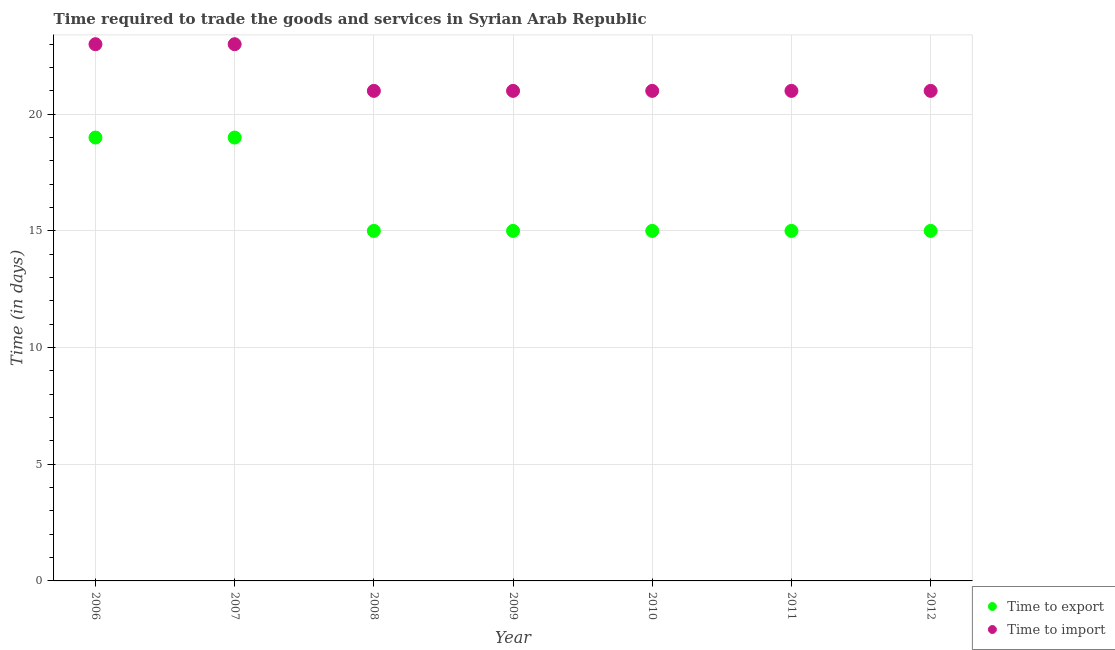How many different coloured dotlines are there?
Give a very brief answer. 2. What is the time to import in 2006?
Offer a terse response. 23. Across all years, what is the maximum time to export?
Your response must be concise. 19. Across all years, what is the minimum time to import?
Your answer should be compact. 21. In which year was the time to import maximum?
Provide a succinct answer. 2006. In which year was the time to export minimum?
Provide a short and direct response. 2008. What is the total time to import in the graph?
Provide a short and direct response. 151. What is the difference between the time to import in 2010 and the time to export in 2012?
Provide a short and direct response. 6. What is the average time to import per year?
Provide a short and direct response. 21.57. In the year 2006, what is the difference between the time to import and time to export?
Your answer should be compact. 4. In how many years, is the time to import greater than 2 days?
Your answer should be very brief. 7. What is the ratio of the time to export in 2007 to that in 2012?
Provide a short and direct response. 1.27. Is the time to import in 2007 less than that in 2009?
Your answer should be compact. No. What is the difference between the highest and the lowest time to import?
Offer a terse response. 2. In how many years, is the time to export greater than the average time to export taken over all years?
Offer a terse response. 2. Is the sum of the time to export in 2007 and 2012 greater than the maximum time to import across all years?
Your answer should be very brief. Yes. Is the time to import strictly greater than the time to export over the years?
Keep it short and to the point. Yes. How many dotlines are there?
Offer a terse response. 2. How many years are there in the graph?
Your answer should be compact. 7. What is the difference between two consecutive major ticks on the Y-axis?
Provide a succinct answer. 5. Does the graph contain any zero values?
Offer a very short reply. No. Where does the legend appear in the graph?
Provide a short and direct response. Bottom right. How are the legend labels stacked?
Provide a short and direct response. Vertical. What is the title of the graph?
Ensure brevity in your answer.  Time required to trade the goods and services in Syrian Arab Republic. What is the label or title of the Y-axis?
Provide a succinct answer. Time (in days). What is the Time (in days) in Time to import in 2006?
Keep it short and to the point. 23. What is the Time (in days) in Time to import in 2007?
Your answer should be compact. 23. What is the Time (in days) of Time to export in 2008?
Offer a very short reply. 15. What is the Time (in days) of Time to import in 2008?
Provide a succinct answer. 21. What is the Time (in days) of Time to import in 2011?
Provide a short and direct response. 21. What is the Time (in days) in Time to export in 2012?
Give a very brief answer. 15. What is the Time (in days) in Time to import in 2012?
Provide a succinct answer. 21. Across all years, what is the minimum Time (in days) in Time to import?
Your response must be concise. 21. What is the total Time (in days) of Time to export in the graph?
Provide a short and direct response. 113. What is the total Time (in days) of Time to import in the graph?
Offer a very short reply. 151. What is the difference between the Time (in days) of Time to export in 2006 and that in 2007?
Ensure brevity in your answer.  0. What is the difference between the Time (in days) of Time to import in 2006 and that in 2007?
Keep it short and to the point. 0. What is the difference between the Time (in days) of Time to export in 2006 and that in 2009?
Offer a terse response. 4. What is the difference between the Time (in days) of Time to import in 2006 and that in 2009?
Offer a terse response. 2. What is the difference between the Time (in days) in Time to export in 2006 and that in 2010?
Offer a terse response. 4. What is the difference between the Time (in days) of Time to export in 2006 and that in 2012?
Offer a terse response. 4. What is the difference between the Time (in days) of Time to import in 2007 and that in 2008?
Your response must be concise. 2. What is the difference between the Time (in days) of Time to export in 2007 and that in 2011?
Your answer should be compact. 4. What is the difference between the Time (in days) in Time to import in 2007 and that in 2011?
Keep it short and to the point. 2. What is the difference between the Time (in days) in Time to export in 2007 and that in 2012?
Give a very brief answer. 4. What is the difference between the Time (in days) in Time to import in 2008 and that in 2010?
Your response must be concise. 0. What is the difference between the Time (in days) of Time to export in 2008 and that in 2012?
Ensure brevity in your answer.  0. What is the difference between the Time (in days) of Time to export in 2009 and that in 2010?
Ensure brevity in your answer.  0. What is the difference between the Time (in days) of Time to export in 2009 and that in 2011?
Keep it short and to the point. 0. What is the difference between the Time (in days) of Time to import in 2009 and that in 2011?
Ensure brevity in your answer.  0. What is the difference between the Time (in days) of Time to import in 2009 and that in 2012?
Provide a succinct answer. 0. What is the difference between the Time (in days) of Time to export in 2010 and that in 2011?
Offer a terse response. 0. What is the difference between the Time (in days) of Time to export in 2010 and that in 2012?
Offer a terse response. 0. What is the difference between the Time (in days) in Time to export in 2006 and the Time (in days) in Time to import in 2008?
Make the answer very short. -2. What is the difference between the Time (in days) in Time to export in 2006 and the Time (in days) in Time to import in 2011?
Provide a succinct answer. -2. What is the difference between the Time (in days) in Time to export in 2006 and the Time (in days) in Time to import in 2012?
Give a very brief answer. -2. What is the difference between the Time (in days) of Time to export in 2007 and the Time (in days) of Time to import in 2008?
Provide a short and direct response. -2. What is the difference between the Time (in days) in Time to export in 2007 and the Time (in days) in Time to import in 2010?
Ensure brevity in your answer.  -2. What is the difference between the Time (in days) in Time to export in 2008 and the Time (in days) in Time to import in 2010?
Keep it short and to the point. -6. What is the difference between the Time (in days) of Time to export in 2008 and the Time (in days) of Time to import in 2011?
Ensure brevity in your answer.  -6. What is the difference between the Time (in days) in Time to export in 2009 and the Time (in days) in Time to import in 2010?
Offer a very short reply. -6. What is the difference between the Time (in days) of Time to export in 2009 and the Time (in days) of Time to import in 2011?
Ensure brevity in your answer.  -6. What is the difference between the Time (in days) in Time to export in 2009 and the Time (in days) in Time to import in 2012?
Your answer should be very brief. -6. What is the difference between the Time (in days) of Time to export in 2010 and the Time (in days) of Time to import in 2011?
Make the answer very short. -6. What is the difference between the Time (in days) in Time to export in 2010 and the Time (in days) in Time to import in 2012?
Provide a succinct answer. -6. What is the difference between the Time (in days) of Time to export in 2011 and the Time (in days) of Time to import in 2012?
Your answer should be compact. -6. What is the average Time (in days) of Time to export per year?
Provide a succinct answer. 16.14. What is the average Time (in days) in Time to import per year?
Your response must be concise. 21.57. In the year 2007, what is the difference between the Time (in days) in Time to export and Time (in days) in Time to import?
Your response must be concise. -4. In the year 2009, what is the difference between the Time (in days) of Time to export and Time (in days) of Time to import?
Your answer should be very brief. -6. In the year 2010, what is the difference between the Time (in days) of Time to export and Time (in days) of Time to import?
Your answer should be very brief. -6. What is the ratio of the Time (in days) in Time to export in 2006 to that in 2007?
Your answer should be compact. 1. What is the ratio of the Time (in days) of Time to export in 2006 to that in 2008?
Offer a very short reply. 1.27. What is the ratio of the Time (in days) of Time to import in 2006 to that in 2008?
Your answer should be very brief. 1.1. What is the ratio of the Time (in days) in Time to export in 2006 to that in 2009?
Keep it short and to the point. 1.27. What is the ratio of the Time (in days) in Time to import in 2006 to that in 2009?
Keep it short and to the point. 1.1. What is the ratio of the Time (in days) of Time to export in 2006 to that in 2010?
Provide a short and direct response. 1.27. What is the ratio of the Time (in days) of Time to import in 2006 to that in 2010?
Offer a very short reply. 1.1. What is the ratio of the Time (in days) of Time to export in 2006 to that in 2011?
Give a very brief answer. 1.27. What is the ratio of the Time (in days) in Time to import in 2006 to that in 2011?
Your response must be concise. 1.1. What is the ratio of the Time (in days) in Time to export in 2006 to that in 2012?
Keep it short and to the point. 1.27. What is the ratio of the Time (in days) in Time to import in 2006 to that in 2012?
Ensure brevity in your answer.  1.1. What is the ratio of the Time (in days) in Time to export in 2007 to that in 2008?
Offer a very short reply. 1.27. What is the ratio of the Time (in days) in Time to import in 2007 to that in 2008?
Ensure brevity in your answer.  1.1. What is the ratio of the Time (in days) in Time to export in 2007 to that in 2009?
Offer a terse response. 1.27. What is the ratio of the Time (in days) of Time to import in 2007 to that in 2009?
Your answer should be compact. 1.1. What is the ratio of the Time (in days) of Time to export in 2007 to that in 2010?
Offer a terse response. 1.27. What is the ratio of the Time (in days) of Time to import in 2007 to that in 2010?
Give a very brief answer. 1.1. What is the ratio of the Time (in days) in Time to export in 2007 to that in 2011?
Your answer should be compact. 1.27. What is the ratio of the Time (in days) in Time to import in 2007 to that in 2011?
Your answer should be very brief. 1.1. What is the ratio of the Time (in days) in Time to export in 2007 to that in 2012?
Your response must be concise. 1.27. What is the ratio of the Time (in days) of Time to import in 2007 to that in 2012?
Provide a succinct answer. 1.1. What is the ratio of the Time (in days) in Time to export in 2008 to that in 2009?
Provide a succinct answer. 1. What is the ratio of the Time (in days) in Time to export in 2008 to that in 2010?
Give a very brief answer. 1. What is the ratio of the Time (in days) in Time to export in 2008 to that in 2011?
Your answer should be very brief. 1. What is the ratio of the Time (in days) in Time to export in 2008 to that in 2012?
Your response must be concise. 1. What is the ratio of the Time (in days) of Time to import in 2008 to that in 2012?
Ensure brevity in your answer.  1. What is the ratio of the Time (in days) of Time to import in 2009 to that in 2010?
Your answer should be compact. 1. What is the ratio of the Time (in days) of Time to export in 2009 to that in 2011?
Keep it short and to the point. 1. What is the ratio of the Time (in days) of Time to import in 2009 to that in 2011?
Offer a very short reply. 1. What is the ratio of the Time (in days) of Time to export in 2009 to that in 2012?
Offer a terse response. 1. What is the ratio of the Time (in days) in Time to import in 2009 to that in 2012?
Ensure brevity in your answer.  1. What is the ratio of the Time (in days) of Time to export in 2010 to that in 2011?
Your answer should be very brief. 1. What is the ratio of the Time (in days) in Time to import in 2010 to that in 2011?
Give a very brief answer. 1. What is the ratio of the Time (in days) of Time to export in 2010 to that in 2012?
Offer a very short reply. 1. What is the difference between the highest and the second highest Time (in days) of Time to export?
Your answer should be compact. 0. What is the difference between the highest and the lowest Time (in days) in Time to export?
Provide a short and direct response. 4. What is the difference between the highest and the lowest Time (in days) in Time to import?
Make the answer very short. 2. 